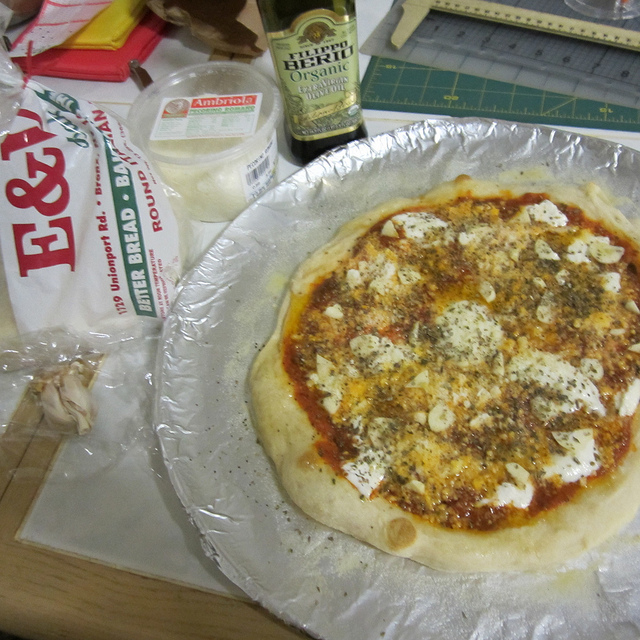Read all the text in this image. E &amp; L Ambriola BERID Berio BERID BETTER BREAD BA Unionport 1720 ROUND IO 